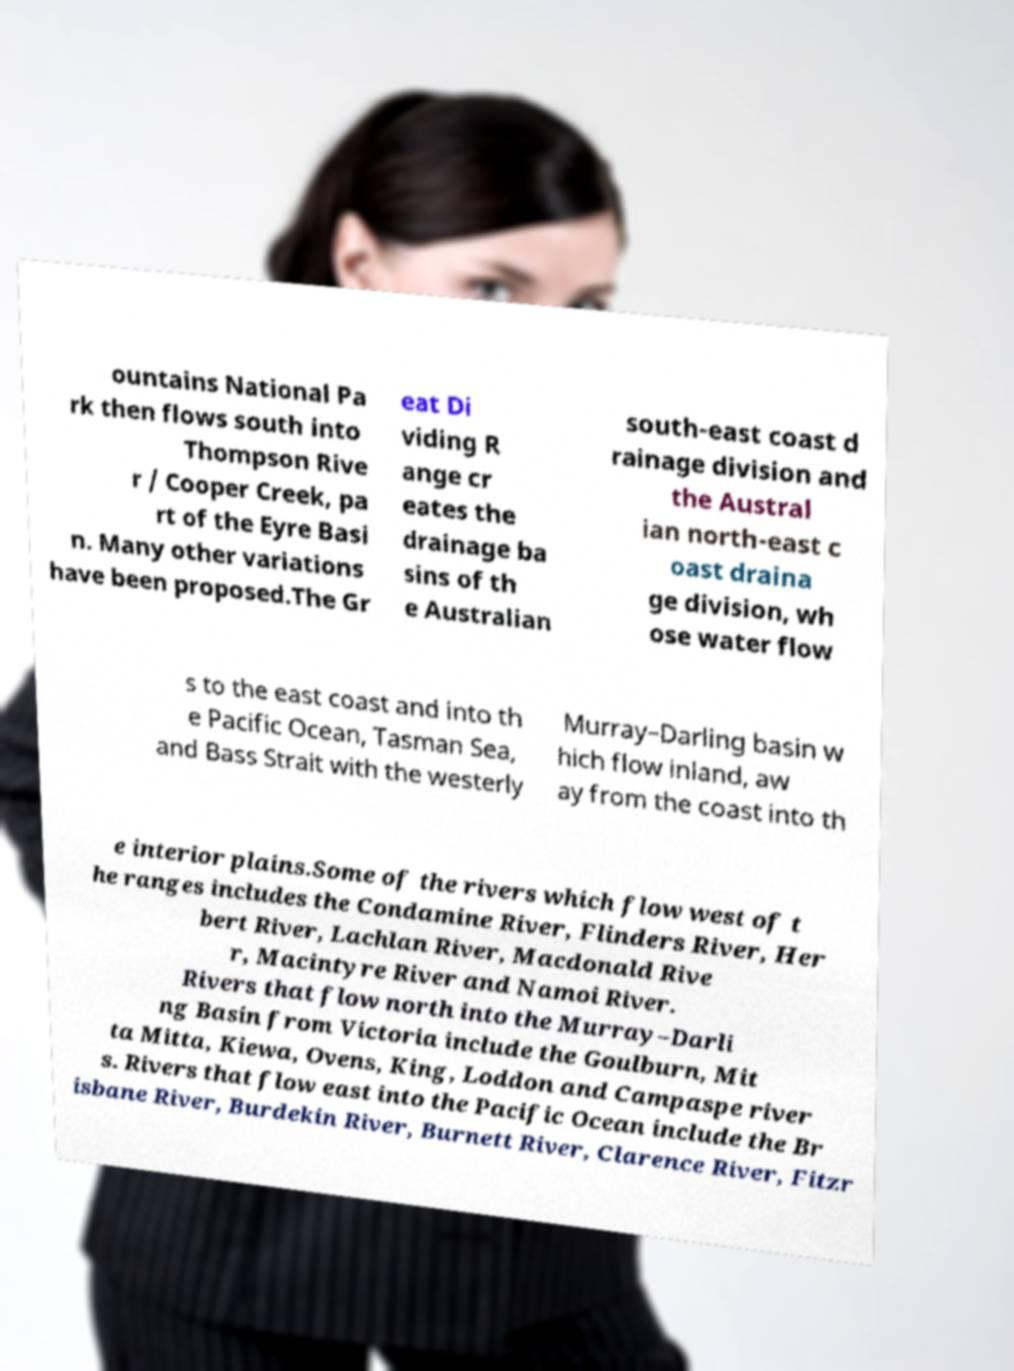There's text embedded in this image that I need extracted. Can you transcribe it verbatim? ountains National Pa rk then flows south into Thompson Rive r / Cooper Creek, pa rt of the Eyre Basi n. Many other variations have been proposed.The Gr eat Di viding R ange cr eates the drainage ba sins of th e Australian south-east coast d rainage division and the Austral ian north-east c oast draina ge division, wh ose water flow s to the east coast and into th e Pacific Ocean, Tasman Sea, and Bass Strait with the westerly Murray–Darling basin w hich flow inland, aw ay from the coast into th e interior plains.Some of the rivers which flow west of t he ranges includes the Condamine River, Flinders River, Her bert River, Lachlan River, Macdonald Rive r, Macintyre River and Namoi River. Rivers that flow north into the Murray–Darli ng Basin from Victoria include the Goulburn, Mit ta Mitta, Kiewa, Ovens, King, Loddon and Campaspe river s. Rivers that flow east into the Pacific Ocean include the Br isbane River, Burdekin River, Burnett River, Clarence River, Fitzr 